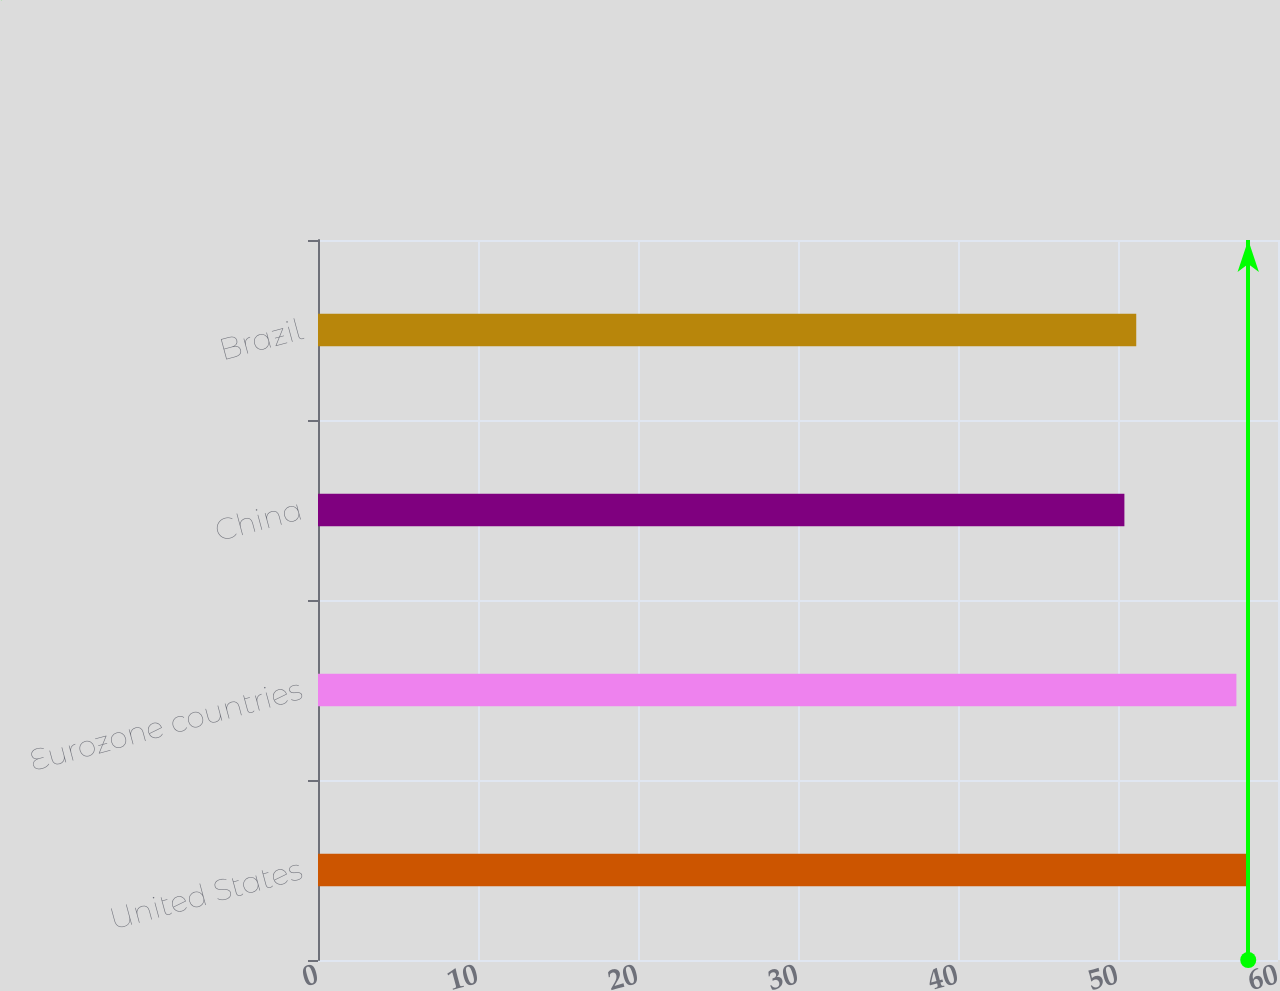<chart> <loc_0><loc_0><loc_500><loc_500><bar_chart><fcel>United States<fcel>Eurozone countries<fcel>China<fcel>Brazil<nl><fcel>58.14<fcel>57.4<fcel>50.4<fcel>51.14<nl></chart> 